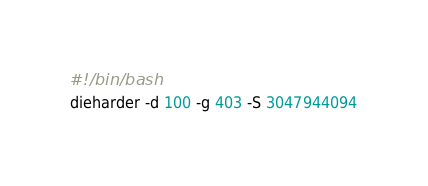<code> <loc_0><loc_0><loc_500><loc_500><_Bash_>#!/bin/bash
dieharder -d 100 -g 403 -S 3047944094
</code> 